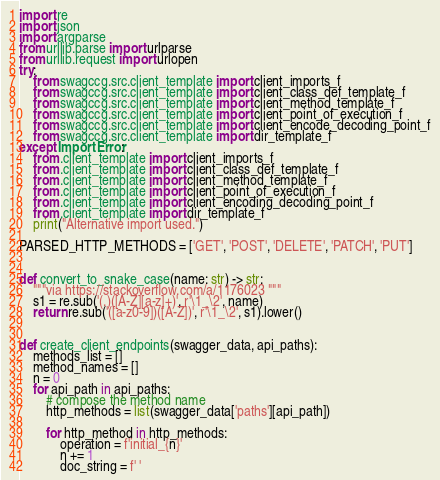<code> <loc_0><loc_0><loc_500><loc_500><_Python_>import re
import json
import argparse
from urllib.parse import urlparse
from urllib.request import urlopen
try:
    from swagccg.src.client_template import client_imports_f
    from swagccg.src.client_template import client_class_def_template_f
    from swagccg.src.client_template import client_method_template_f
    from swagccg.src.client_template import client_point_of_execution_f
    from swagccg.src.client_template import client_encode_decoding_point_f
    from swagccg.src.client_template import dir_template_f
except ImportError:
    from .client_template import client_imports_f
    from .client_template import client_class_def_template_f
    from .client_template import client_method_template_f
    from .client_template import client_point_of_execution_f
    from .client_template import client_encoding_decoding_point_f
    from .client_template import dir_template_f
    print("Alternative import used.")

PARSED_HTTP_METHODS = ['GET', 'POST', 'DELETE', 'PATCH', 'PUT']


def convert_to_snake_case(name: str) -> str:
    """via https://stackoverflow.com/a/1176023 """
    s1 = re.sub('(.)([A-Z][a-z]+)', r'\1_\2', name)
    return re.sub('([a-z0-9])([A-Z])', r'\1_\2', s1).lower()


def create_client_endpoints(swagger_data, api_paths):
    methods_list = []
    method_names = []
    n = 0
    for api_path in api_paths:
        # compose the method name
        http_methods = list(swagger_data['paths'][api_path])

        for http_method in http_methods:
            operation = f'initial_{n}'
            n += 1
            doc_string = f' '</code> 